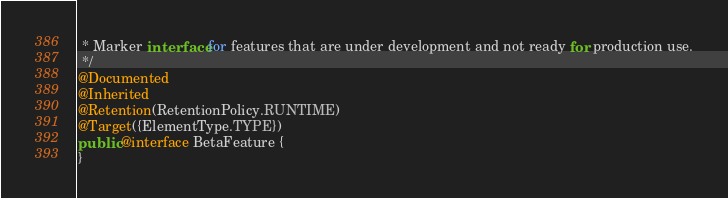Convert code to text. <code><loc_0><loc_0><loc_500><loc_500><_Java_> * Marker interface for features that are under development and not ready for production use.
 */
@Documented
@Inherited
@Retention(RetentionPolicy.RUNTIME)
@Target({ElementType.TYPE})
public @interface BetaFeature {
}
</code> 